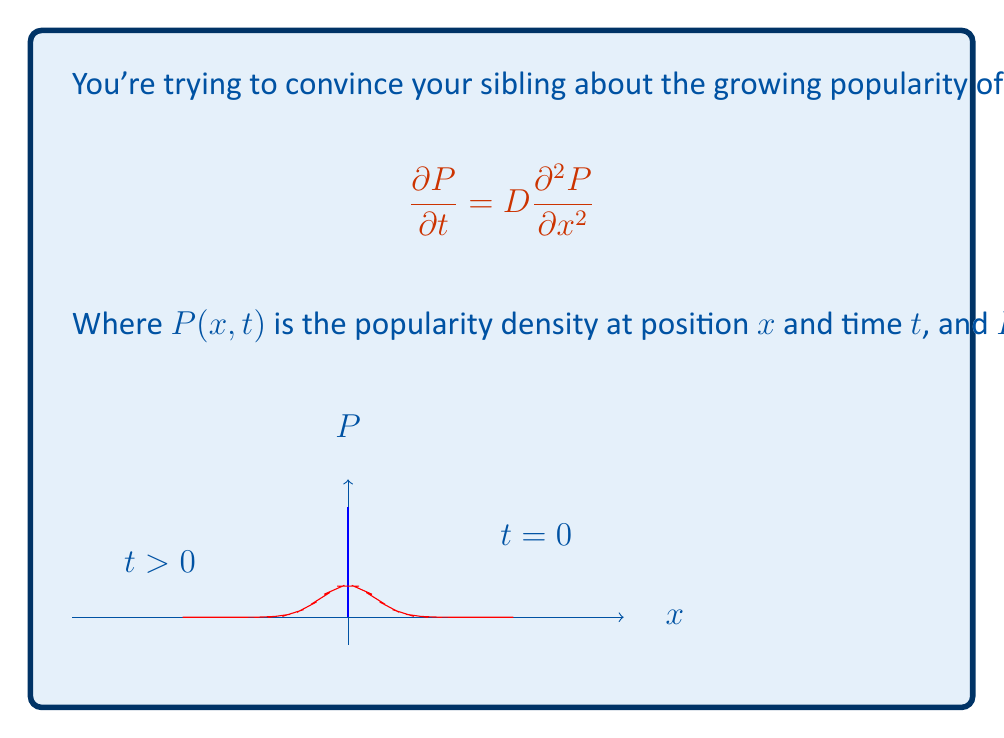Provide a solution to this math problem. Let's solve this step-by-step:

1) The general solution to the 1D diffusion equation is:

   $$P(x,t) = \frac{1}{\sqrt{4\pi Dt}} \exp\left(-\frac{x^2}{4Dt}\right)$$

2) This solution satisfies the initial condition:
   
   $$\lim_{t \to 0} P(x,t) = \delta(x)$$

3) To verify, we can check if it satisfies the diffusion equation:

   $$\frac{\partial P}{\partial t} = \frac{\partial}{\partial t}\left[\frac{1}{\sqrt{4\pi Dt}} \exp\left(-\frac{x^2}{4Dt}\right)\right]$$
   
   $$= -\frac{1}{2t}P + \frac{x^2}{4Dt^2}P$$

   $$\frac{\partial^2 P}{\partial x^2} = \frac{\partial}{\partial x}\left[-\frac{x}{2Dt}P\right] = -\frac{1}{2Dt}P + \frac{x^2}{4D^2t^2}P$$

4) Multiplying the second equation by $D$:

   $$D\frac{\partial^2 P}{\partial x^2} = -\frac{1}{2t}P + \frac{x^2}{4Dt^2}P$$

5) This is identical to $\frac{\partial P}{\partial t}$, confirming that our solution satisfies the diffusion equation.

Therefore, the solution $P(x,t)$ for $t>0$ is:

$$P(x,t) = \frac{1}{\sqrt{4\pi Dt}} \exp\left(-\frac{x^2}{4Dt}\right)$$

This represents a Gaussian distribution that spreads out over time, modeling how the team's popularity diffuses from its initial concentration.
Answer: $P(x,t) = \frac{1}{\sqrt{4\pi Dt}} \exp\left(-\frac{x^2}{4Dt}\right)$ 